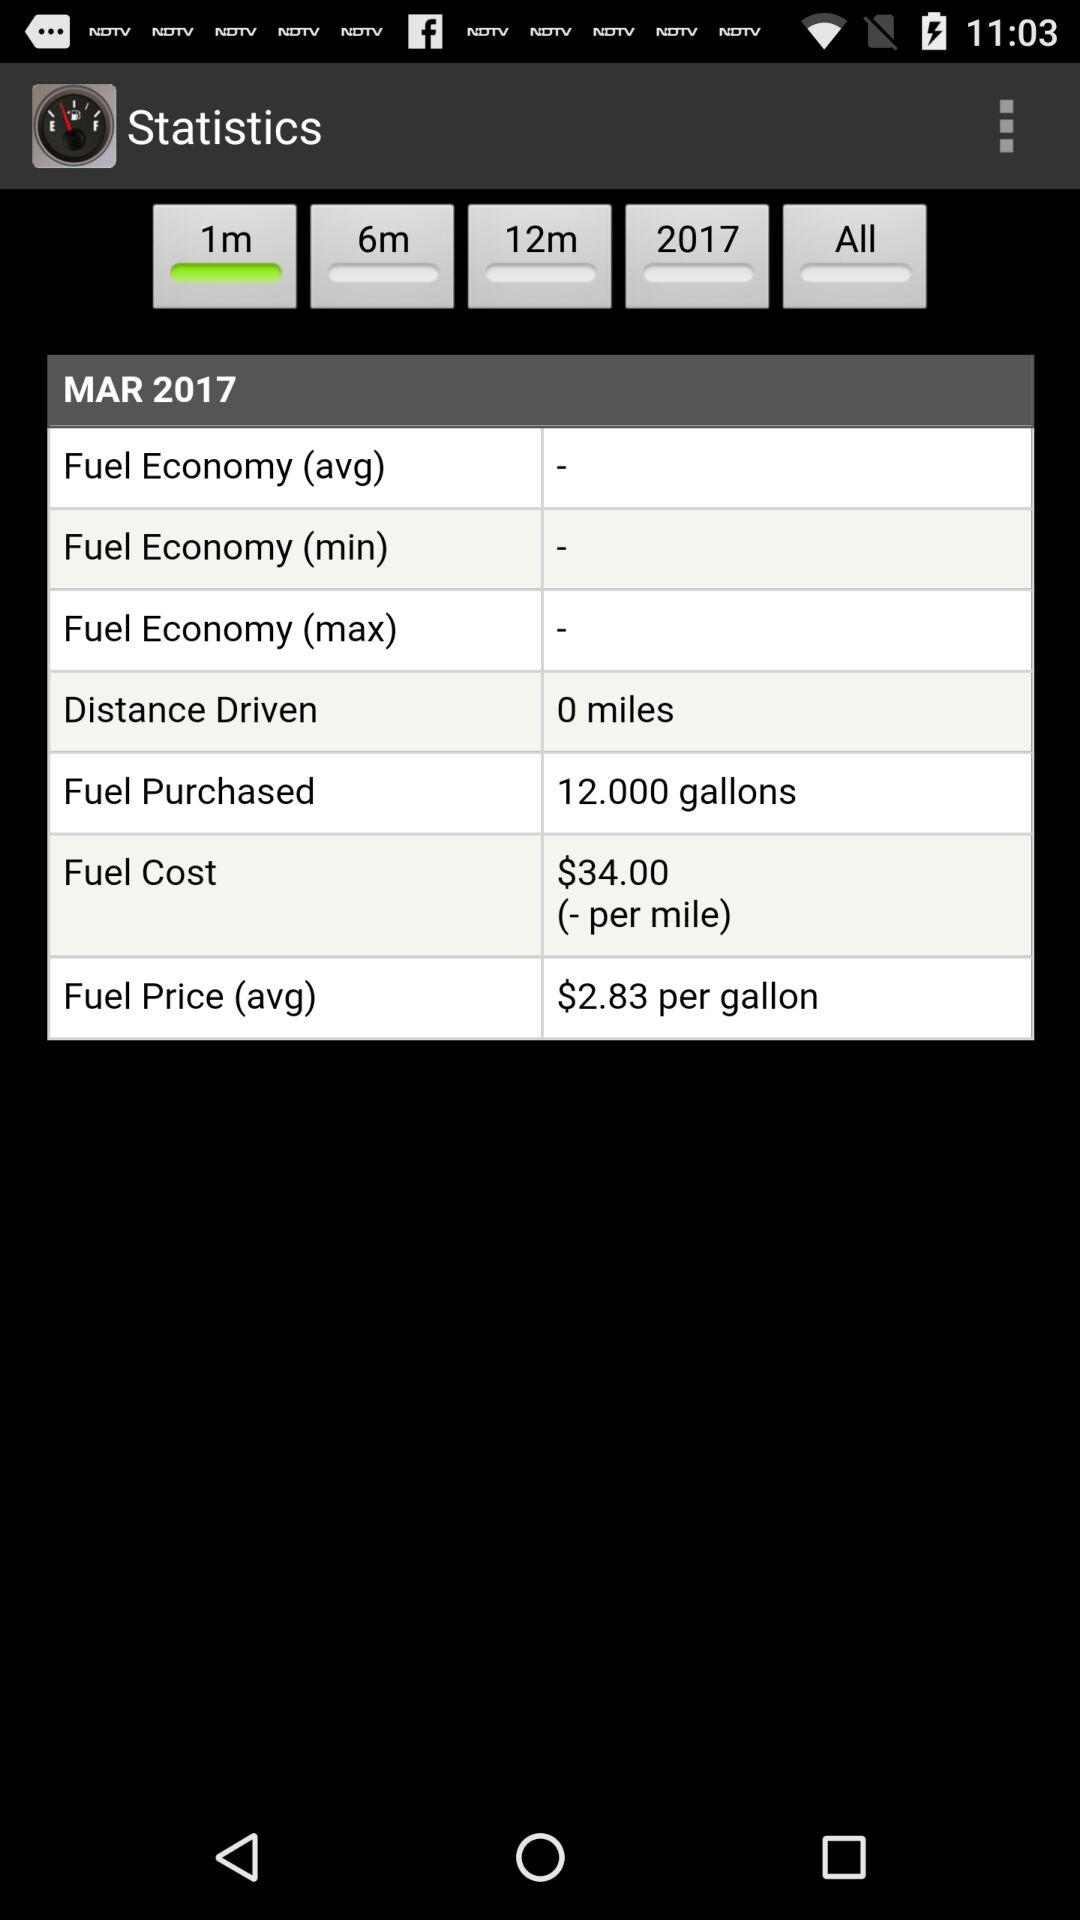What is the cost of the fuel? The cost of the fuel is $34.00 (- per mile). 